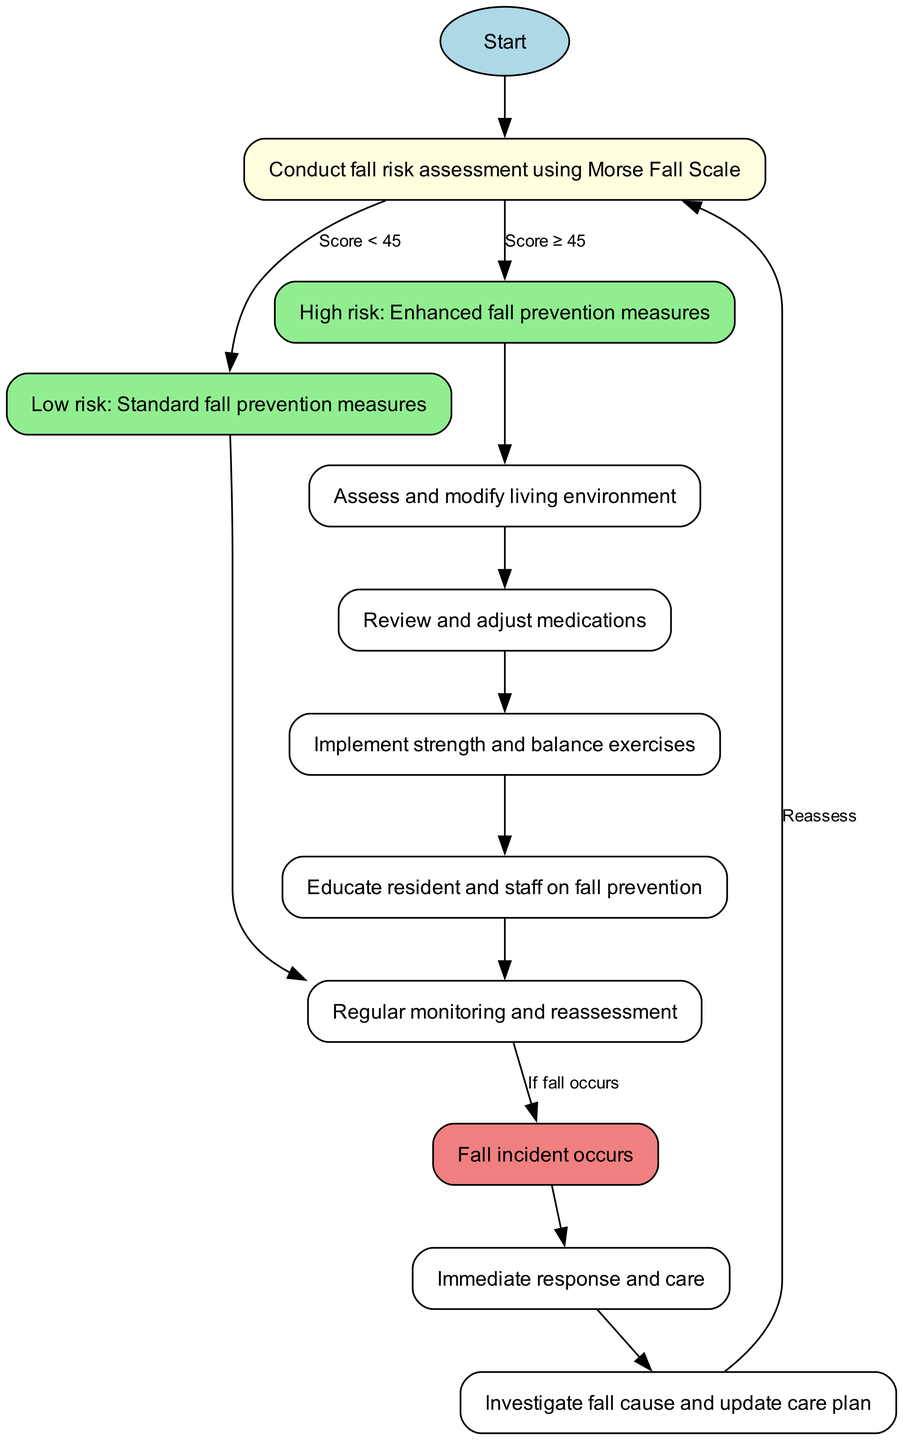What is the first step in the pathway? The diagram starts with the node labeled "Fall Risk Assessment." This is indicated at the top of the diagram before any other nodes are connected.
Answer: Fall Risk Assessment What is the score threshold for high-risk fall prevention measures? According to the diagram, the threshold for high risk is indicated as "Score ≥ 45." This means that if the assessment score is equal to or greater than 45, heightened measures are required.
Answer: Score ≥ 45 How many nodes represent interventions in the diagram? The interventions in the pathway include nodes labeled as "Assess and modify living environment," "Review and adjust medications," "Implement strength and balance exercises," and "Educate resident and staff on fall prevention." There are four intervention nodes in total.
Answer: 4 What happens if a fall incident occurs? The diagram flows from the "Regular monitoring and reassessment" node to the "Fall incident occurs" node, indicating that an incident triggers the next action. This leads to a direct response and care given immediately after the occurrence.
Answer: Immediate response and care What is the last step that loops back to the assessment? After the "Investigate fall cause and update care plan," the pathway points back to the "Conduct fall risk assessment using Morse Fall Scale." This is a reiteration of continuous improvement in the care process by reassessing fall risks.
Answer: Reassess What node follows after the "high risk" node? According to the connections in the diagram, the node that follows after "High risk: Enhanced fall prevention measures" is "Assess and modify living environment." This indicates a sequence of actions to be taken for individuals assessed at high risk.
Answer: Assess and modify living environment What type of fall prevention measures are taken for low-risk residents? For residents categorized as low risk, the pathway directs to the node labeled "Standard fall prevention measures," indicating basic precautions are implemented without additional enhancements.
Answer: Standard fall prevention measures 